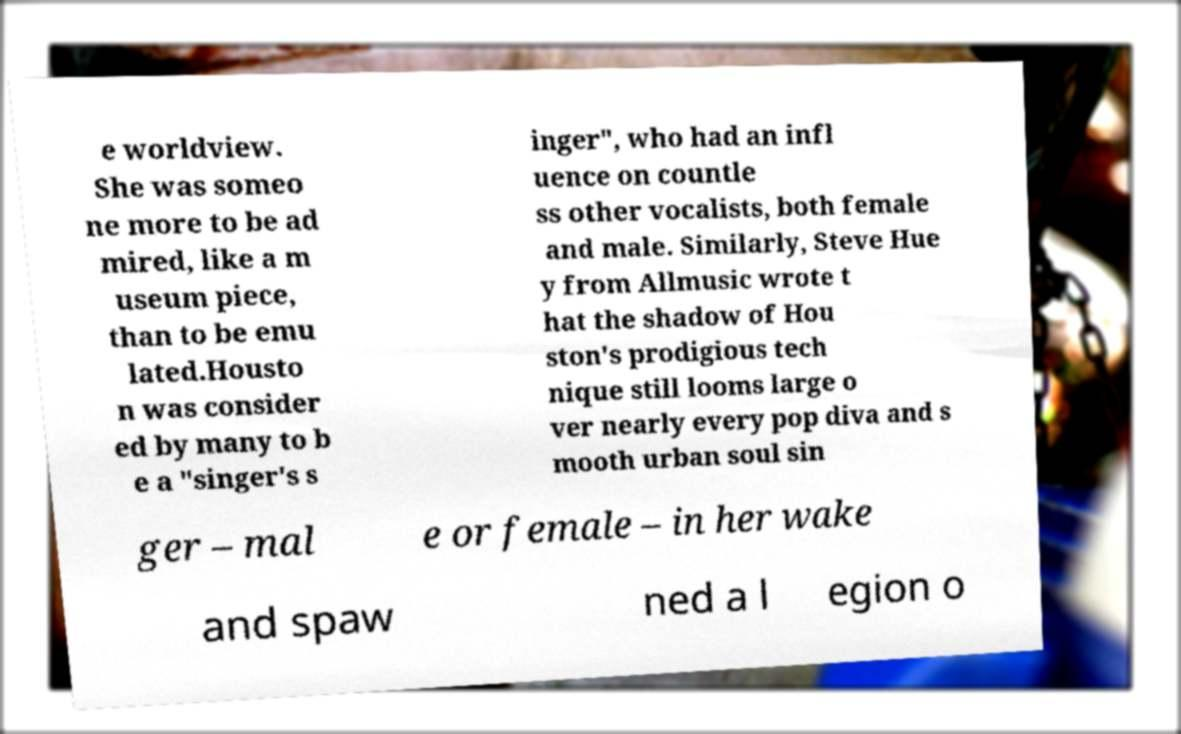Could you assist in decoding the text presented in this image and type it out clearly? e worldview. She was someo ne more to be ad mired, like a m useum piece, than to be emu lated.Housto n was consider ed by many to b e a "singer's s inger", who had an infl uence on countle ss other vocalists, both female and male. Similarly, Steve Hue y from Allmusic wrote t hat the shadow of Hou ston's prodigious tech nique still looms large o ver nearly every pop diva and s mooth urban soul sin ger – mal e or female – in her wake and spaw ned a l egion o 